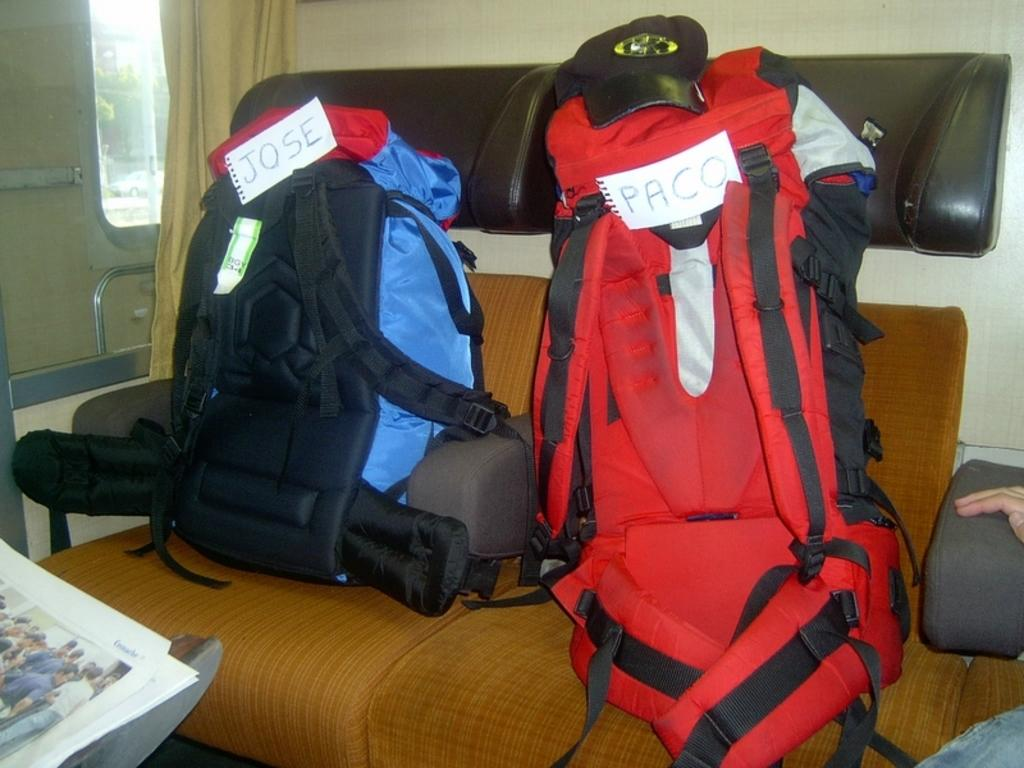<image>
Create a compact narrative representing the image presented. two seperate backpacks that says jose and paco 